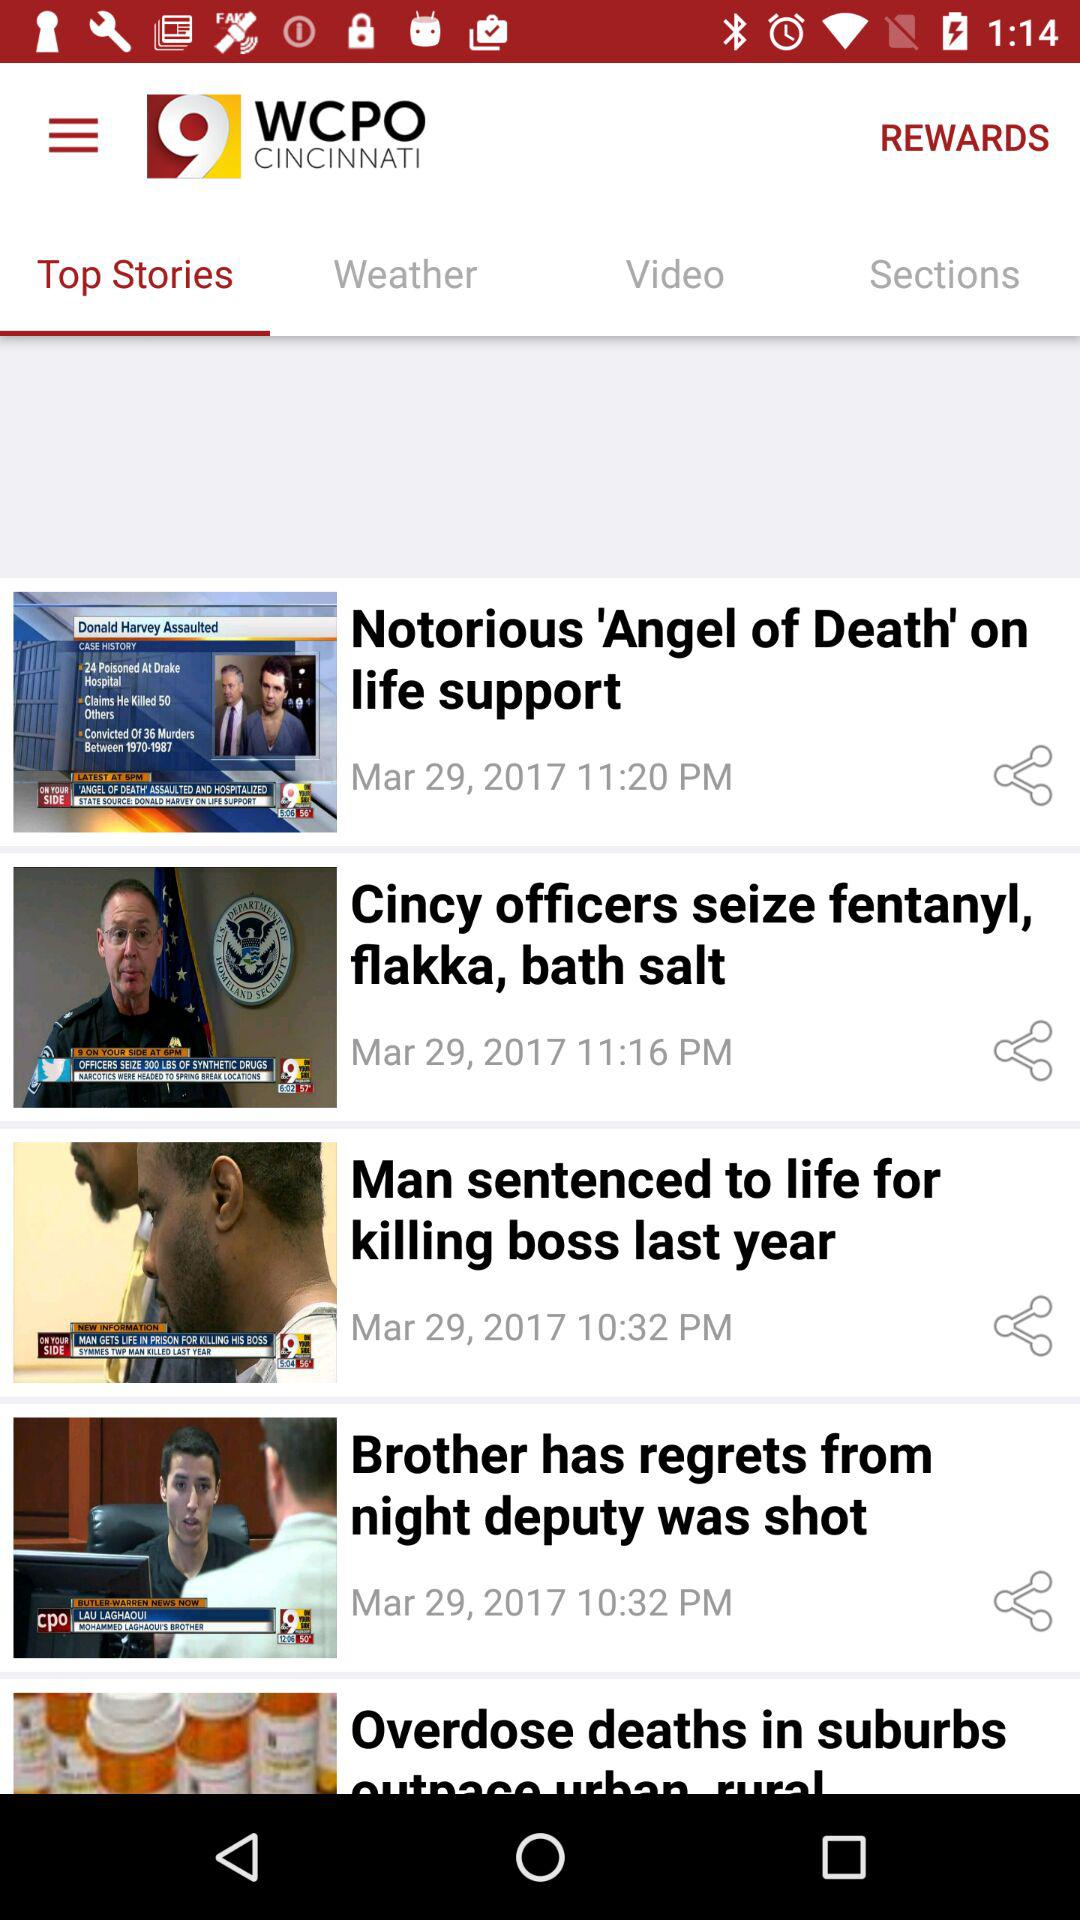What is the story posted at 11:20 pm on March 29, 2017? The story is "Notorious 'Angel of Death' on life support". 